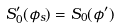<formula> <loc_0><loc_0><loc_500><loc_500>S _ { 0 } ^ { \prime } ( \phi _ { s } ) = S _ { 0 } ( \phi ^ { \prime } )</formula> 